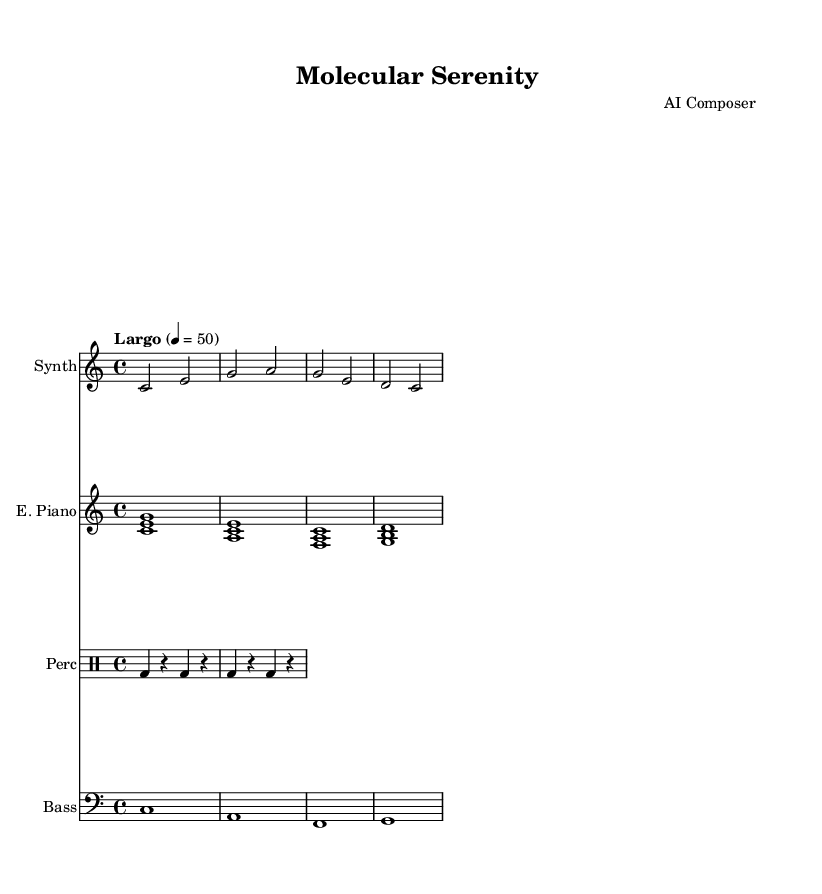What is the key signature of this music? The key signature is C major, which can be identified by looking for no sharps or flats listed at the beginning of the staff. In C major, all notes are naturally formatted without additional alterations.
Answer: C major What is the time signature of this music? The time signature is 4/4, which can be found next to the clef at the beginning of the sheet music. This indicates that there are four beats per measure, and the quarter note gets one beat.
Answer: 4/4 What is the tempo marking of this music? The tempo marking is "Largo", which can be seen above the music and indicates a slow tempo, typically around 40-60 beats per minute.
Answer: Largo How many measures are there in the synthesizer part? By counting the distinct groupings of notes separated by vertical lines (bar lines) in the synthesizer part, we see there are four measures.
Answer: 4 Which instrument plays the bass line? The bass line is specifically written for the instrument labeled as "Bass," which is indicated at the start of the corresponding staff in the sheet music.
Answer: Bass How many different instruments are featured in this piece? The score shows four distinct staves for different instruments: Synth, E. Piano, Perc, and Bass. Therefore, when counting these labeled instruments, we find there are four in total.
Answer: 4 Which instrument features the rhythmic pattern? The rhythmic pattern is primarily found in the "Perc" staff, identified by the drummode notation, showing a focus on typical drum rhythms like bass drum hits and rests.
Answer: Perc 